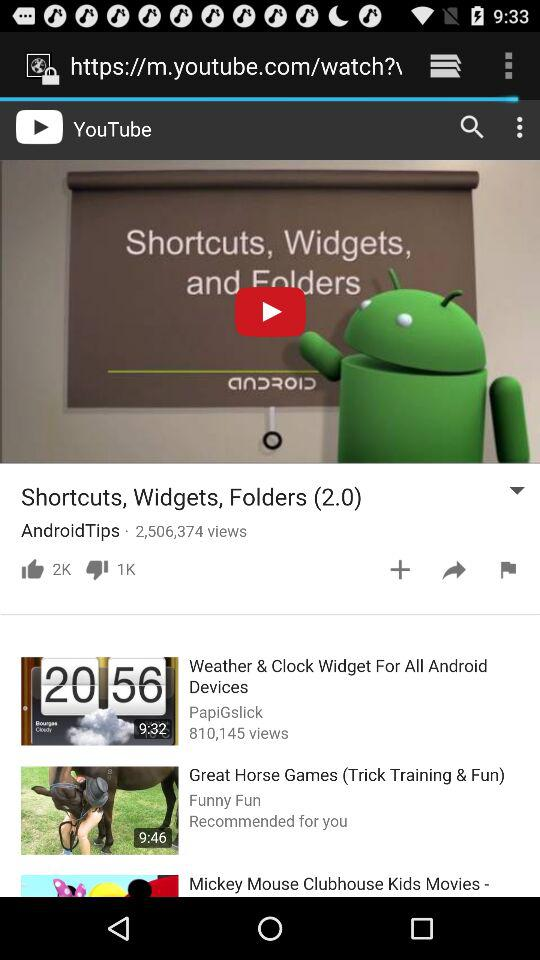How many likes are on the video? The likes on the video are 2K. 